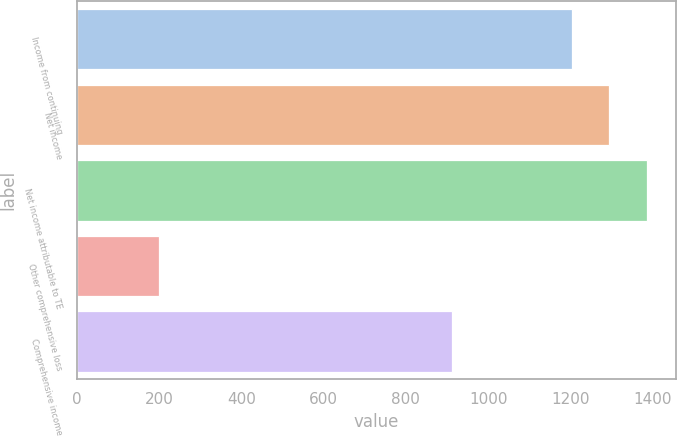Convert chart. <chart><loc_0><loc_0><loc_500><loc_500><bar_chart><fcel>Income from continuing<fcel>Net income<fcel>Net income attributable to TE<fcel>Other comprehensive loss<fcel>Comprehensive income<nl><fcel>1203.3<fcel>1294.6<fcel>1385.9<fcel>199<fcel>913<nl></chart> 